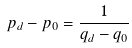<formula> <loc_0><loc_0><loc_500><loc_500>p _ { d } - p _ { 0 } = \frac { 1 } { q _ { d } - q _ { 0 } }</formula> 